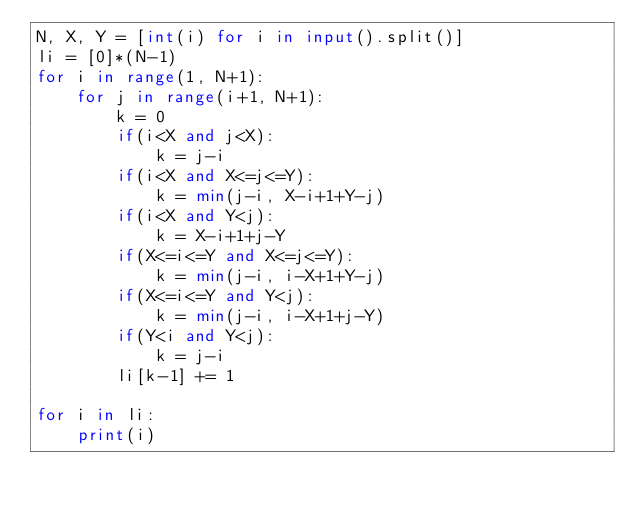<code> <loc_0><loc_0><loc_500><loc_500><_Python_>N, X, Y = [int(i) for i in input().split()]
li = [0]*(N-1)
for i in range(1, N+1):
    for j in range(i+1, N+1):
        k = 0
        if(i<X and j<X):
            k = j-i
        if(i<X and X<=j<=Y):
            k = min(j-i, X-i+1+Y-j)
        if(i<X and Y<j):
            k = X-i+1+j-Y
        if(X<=i<=Y and X<=j<=Y):
            k = min(j-i, i-X+1+Y-j)
        if(X<=i<=Y and Y<j):
            k = min(j-i, i-X+1+j-Y)
        if(Y<i and Y<j):
            k = j-i
        li[k-1] += 1

for i in li:
    print(i)
</code> 